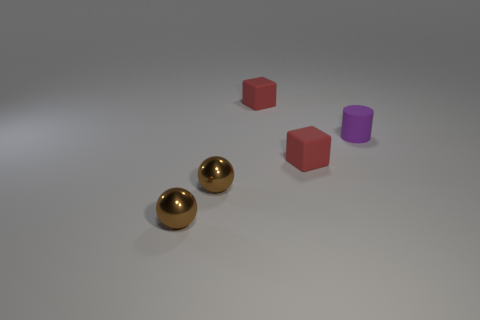Is the number of small red matte cubes that are right of the tiny purple matte cylinder greater than the number of small cylinders?
Give a very brief answer. No. Is there anything else that is the same material as the cylinder?
Keep it short and to the point. Yes. What is the color of the cube left of the tiny red rubber object that is to the right of the tiny thing behind the small purple object?
Give a very brief answer. Red. There is a red thing behind the small purple rubber thing; does it have the same shape as the purple object?
Your answer should be very brief. No. How many brown balls are there?
Give a very brief answer. 2. How many spheres are the same size as the matte cylinder?
Give a very brief answer. 2. What is the purple cylinder made of?
Provide a succinct answer. Rubber. There is a tiny matte cylinder; does it have the same color as the small rubber block that is behind the small purple matte thing?
Keep it short and to the point. No. Is there any other thing that has the same size as the purple thing?
Ensure brevity in your answer.  Yes. Is the small cylinder made of the same material as the red object that is behind the tiny purple matte cylinder?
Offer a terse response. Yes. 